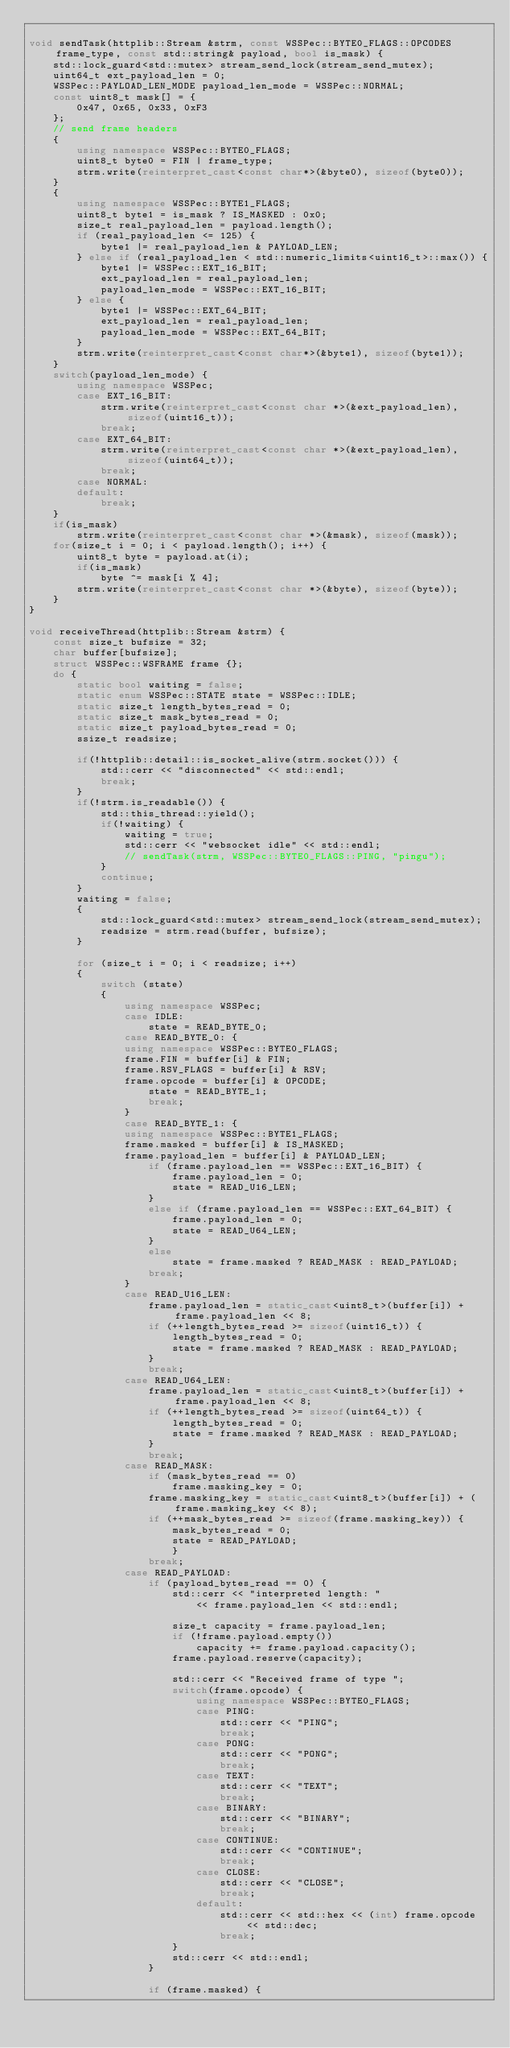Convert code to text. <code><loc_0><loc_0><loc_500><loc_500><_C++_>
void sendTask(httplib::Stream &strm, const WSSPec::BYTE0_FLAGS::OPCODES frame_type, const std::string& payload, bool is_mask) {
    std::lock_guard<std::mutex> stream_send_lock(stream_send_mutex);
    uint64_t ext_payload_len = 0;
    WSSPec::PAYLOAD_LEN_MODE payload_len_mode = WSSPec::NORMAL;
    const uint8_t mask[] = {
        0x47, 0x65, 0x33, 0xF3
    };
    // send frame headers
    {
        using namespace WSSPec::BYTE0_FLAGS;
        uint8_t byte0 = FIN | frame_type;
        strm.write(reinterpret_cast<const char*>(&byte0), sizeof(byte0));
    }
    {
        using namespace WSSPec::BYTE1_FLAGS;
        uint8_t byte1 = is_mask ? IS_MASKED : 0x0;
        size_t real_payload_len = payload.length();
        if (real_payload_len <= 125) {
            byte1 |= real_payload_len & PAYLOAD_LEN;
        } else if (real_payload_len < std::numeric_limits<uint16_t>::max()) {
            byte1 |= WSSPec::EXT_16_BIT;
            ext_payload_len = real_payload_len;
            payload_len_mode = WSSPec::EXT_16_BIT;
        } else {
            byte1 |= WSSPec::EXT_64_BIT;
            ext_payload_len = real_payload_len;
            payload_len_mode = WSSPec::EXT_64_BIT;
        }
        strm.write(reinterpret_cast<const char*>(&byte1), sizeof(byte1));
    }
    switch(payload_len_mode) {
        using namespace WSSPec;
        case EXT_16_BIT:
            strm.write(reinterpret_cast<const char *>(&ext_payload_len), sizeof(uint16_t));
            break;
        case EXT_64_BIT:
            strm.write(reinterpret_cast<const char *>(&ext_payload_len), sizeof(uint64_t));
            break;
        case NORMAL:
        default:
            break;
    }
    if(is_mask)
        strm.write(reinterpret_cast<const char *>(&mask), sizeof(mask));
    for(size_t i = 0; i < payload.length(); i++) {
        uint8_t byte = payload.at(i);
        if(is_mask)
            byte ^= mask[i % 4];
        strm.write(reinterpret_cast<const char *>(&byte), sizeof(byte));
    }
}

void receiveThread(httplib::Stream &strm) {
    const size_t bufsize = 32;
    char buffer[bufsize];
    struct WSSPec::WSFRAME frame {};
    do {
        static bool waiting = false;
        static enum WSSPec::STATE state = WSSPec::IDLE;
        static size_t length_bytes_read = 0;
        static size_t mask_bytes_read = 0;
        static size_t payload_bytes_read = 0;
        ssize_t readsize;

        if(!httplib::detail::is_socket_alive(strm.socket())) {
            std::cerr << "disconnected" << std::endl;
            break;
        }
        if(!strm.is_readable()) {
            std::this_thread::yield();
            if(!waiting) {
                waiting = true;
                std::cerr << "websocket idle" << std::endl;
                // sendTask(strm, WSSPec::BYTE0_FLAGS::PING, "pingu");
            }
            continue;
        }
        waiting = false;
        {
            std::lock_guard<std::mutex> stream_send_lock(stream_send_mutex);
            readsize = strm.read(buffer, bufsize);
        }

        for (size_t i = 0; i < readsize; i++)
        {
            switch (state)
            {
                using namespace WSSPec;
                case IDLE:
                    state = READ_BYTE_0;
                case READ_BYTE_0: {
                using namespace WSSPec::BYTE0_FLAGS;
                frame.FIN = buffer[i] & FIN;
                frame.RSV_FLAGS = buffer[i] & RSV;
                frame.opcode = buffer[i] & OPCODE;
                    state = READ_BYTE_1;
                    break;
                }
                case READ_BYTE_1: {
                using namespace WSSPec::BYTE1_FLAGS;
                frame.masked = buffer[i] & IS_MASKED;
                frame.payload_len = buffer[i] & PAYLOAD_LEN;
                    if (frame.payload_len == WSSPec::EXT_16_BIT) {
                        frame.payload_len = 0;
                        state = READ_U16_LEN;
                    }
                    else if (frame.payload_len == WSSPec::EXT_64_BIT) {
                        frame.payload_len = 0;
                        state = READ_U64_LEN;
                    }
                    else
                        state = frame.masked ? READ_MASK : READ_PAYLOAD;
                    break;
                }
                case READ_U16_LEN:
                    frame.payload_len = static_cast<uint8_t>(buffer[i]) + frame.payload_len << 8;
                    if (++length_bytes_read >= sizeof(uint16_t)) {
                        length_bytes_read = 0;
                        state = frame.masked ? READ_MASK : READ_PAYLOAD;
                    }
                    break;
                case READ_U64_LEN:
                    frame.payload_len = static_cast<uint8_t>(buffer[i]) + frame.payload_len << 8;
                    if (++length_bytes_read >= sizeof(uint64_t)) {
                        length_bytes_read = 0;
                        state = frame.masked ? READ_MASK : READ_PAYLOAD;
                    }
                    break;
                case READ_MASK:
                    if (mask_bytes_read == 0)
                        frame.masking_key = 0;
                    frame.masking_key = static_cast<uint8_t>(buffer[i]) + (frame.masking_key << 8);
                    if (++mask_bytes_read >= sizeof(frame.masking_key)) {
                        mask_bytes_read = 0;
                        state = READ_PAYLOAD;
                        }
                    break;
                case READ_PAYLOAD:
                    if (payload_bytes_read == 0) {
                        std::cerr << "interpreted length: "
                            << frame.payload_len << std::endl;

                        size_t capacity = frame.payload_len;
                        if (!frame.payload.empty())
                            capacity += frame.payload.capacity();
                        frame.payload.reserve(capacity);

                        std::cerr << "Received frame of type ";
                        switch(frame.opcode) {
                            using namespace WSSPec::BYTE0_FLAGS;
                            case PING:
                                std::cerr << "PING";
                                break;
                            case PONG:
                                std::cerr << "PONG";
                                break;
                            case TEXT:
                                std::cerr << "TEXT";
                                break;
                            case BINARY:
                                std::cerr << "BINARY";
                                break;
                            case CONTINUE:
                                std::cerr << "CONTINUE";
                                break;
                            case CLOSE:
                                std::cerr << "CLOSE";
                                break;
                            default:
                                std::cerr << std::hex << (int) frame.opcode << std::dec;
                                break;
                        }
                        std::cerr << std::endl;
                    }

                    if (frame.masked) {</code> 